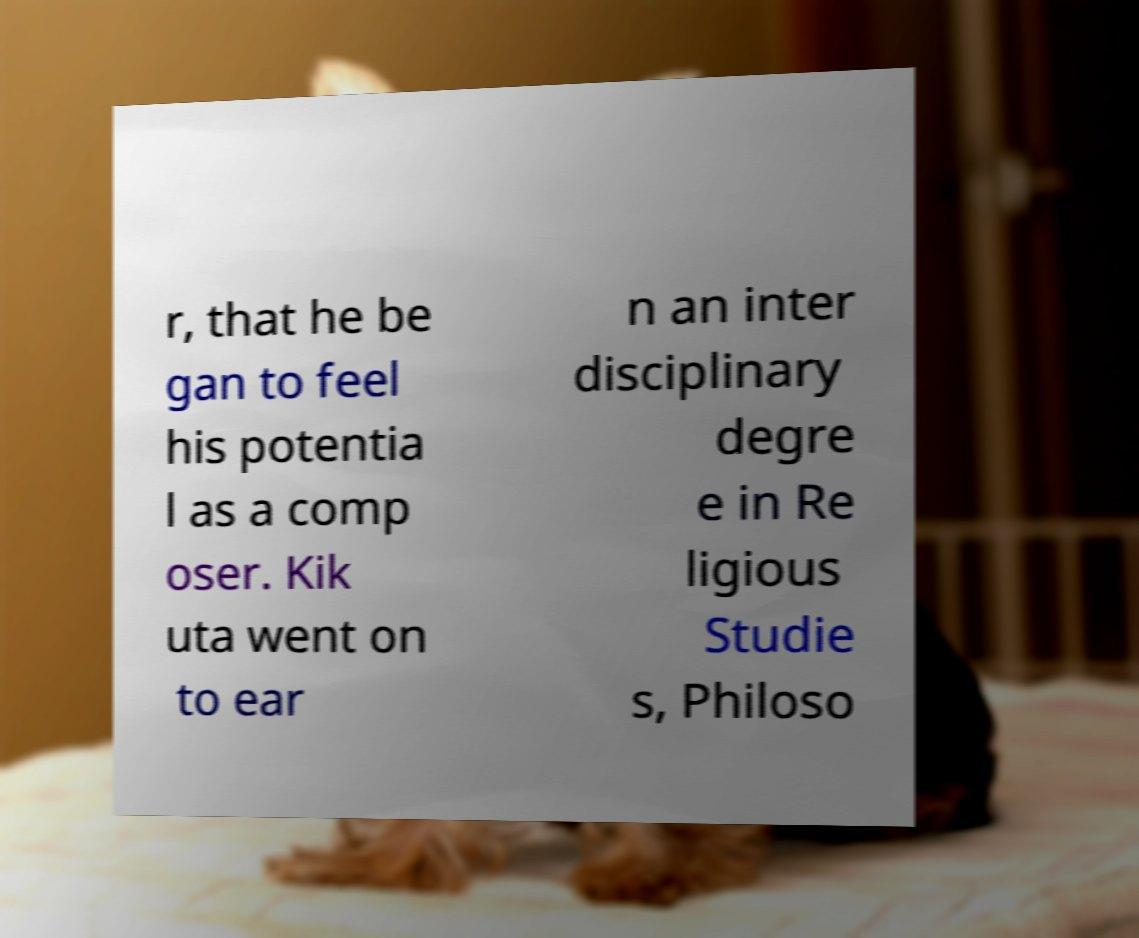Could you extract and type out the text from this image? r, that he be gan to feel his potentia l as a comp oser. Kik uta went on to ear n an inter disciplinary degre e in Re ligious Studie s, Philoso 